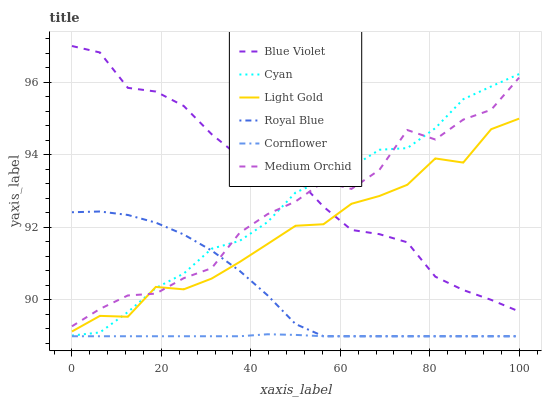Does Cornflower have the minimum area under the curve?
Answer yes or no. Yes. Does Blue Violet have the maximum area under the curve?
Answer yes or no. Yes. Does Medium Orchid have the minimum area under the curve?
Answer yes or no. No. Does Medium Orchid have the maximum area under the curve?
Answer yes or no. No. Is Cornflower the smoothest?
Answer yes or no. Yes. Is Medium Orchid the roughest?
Answer yes or no. Yes. Is Royal Blue the smoothest?
Answer yes or no. No. Is Royal Blue the roughest?
Answer yes or no. No. Does Cornflower have the lowest value?
Answer yes or no. Yes. Does Medium Orchid have the lowest value?
Answer yes or no. No. Does Blue Violet have the highest value?
Answer yes or no. Yes. Does Medium Orchid have the highest value?
Answer yes or no. No. Is Cornflower less than Cyan?
Answer yes or no. Yes. Is Cyan greater than Cornflower?
Answer yes or no. Yes. Does Cyan intersect Medium Orchid?
Answer yes or no. Yes. Is Cyan less than Medium Orchid?
Answer yes or no. No. Is Cyan greater than Medium Orchid?
Answer yes or no. No. Does Cornflower intersect Cyan?
Answer yes or no. No. 